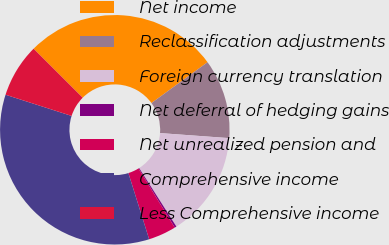Convert chart to OTSL. <chart><loc_0><loc_0><loc_500><loc_500><pie_chart><fcel>Net income<fcel>Reclassification adjustments<fcel>Foreign currency translation<fcel>Net deferral of hedging gains<fcel>Net unrealized pension and<fcel>Comprehensive income<fcel>Less Comprehensive income<nl><fcel>27.5%<fcel>11.18%<fcel>14.82%<fcel>0.27%<fcel>3.91%<fcel>34.78%<fcel>7.54%<nl></chart> 